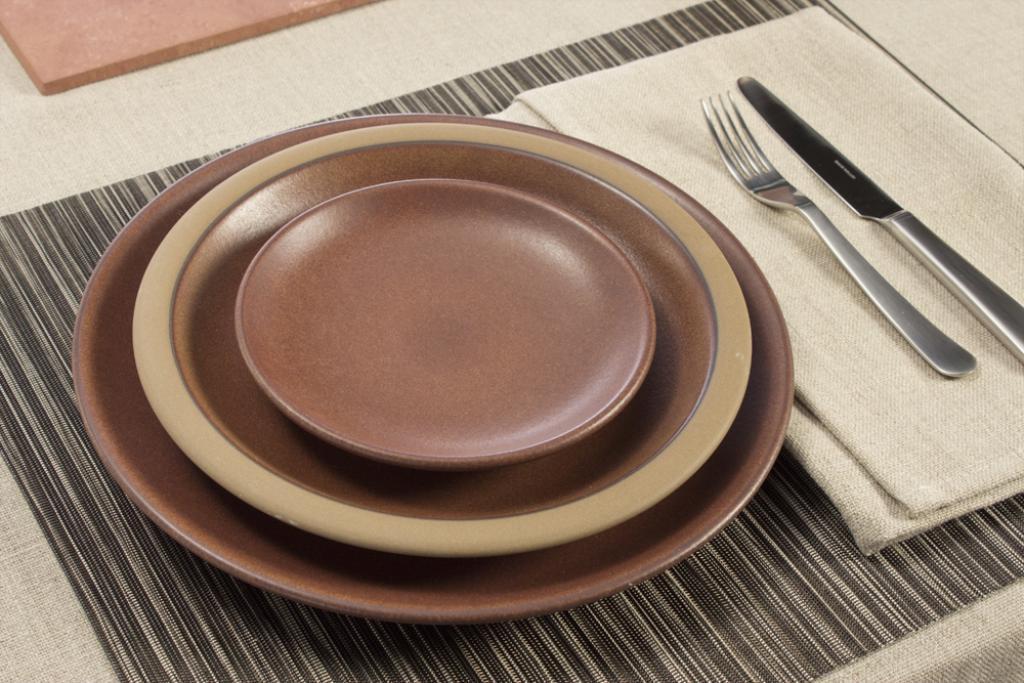In one or two sentences, can you explain what this image depicts? In this picture there are two plates placed on the top of the other plate and there is a fork and knife on the cloth. At the bottom there is a table mat and there is an object on the table and the table is covered with cream color cloth. 